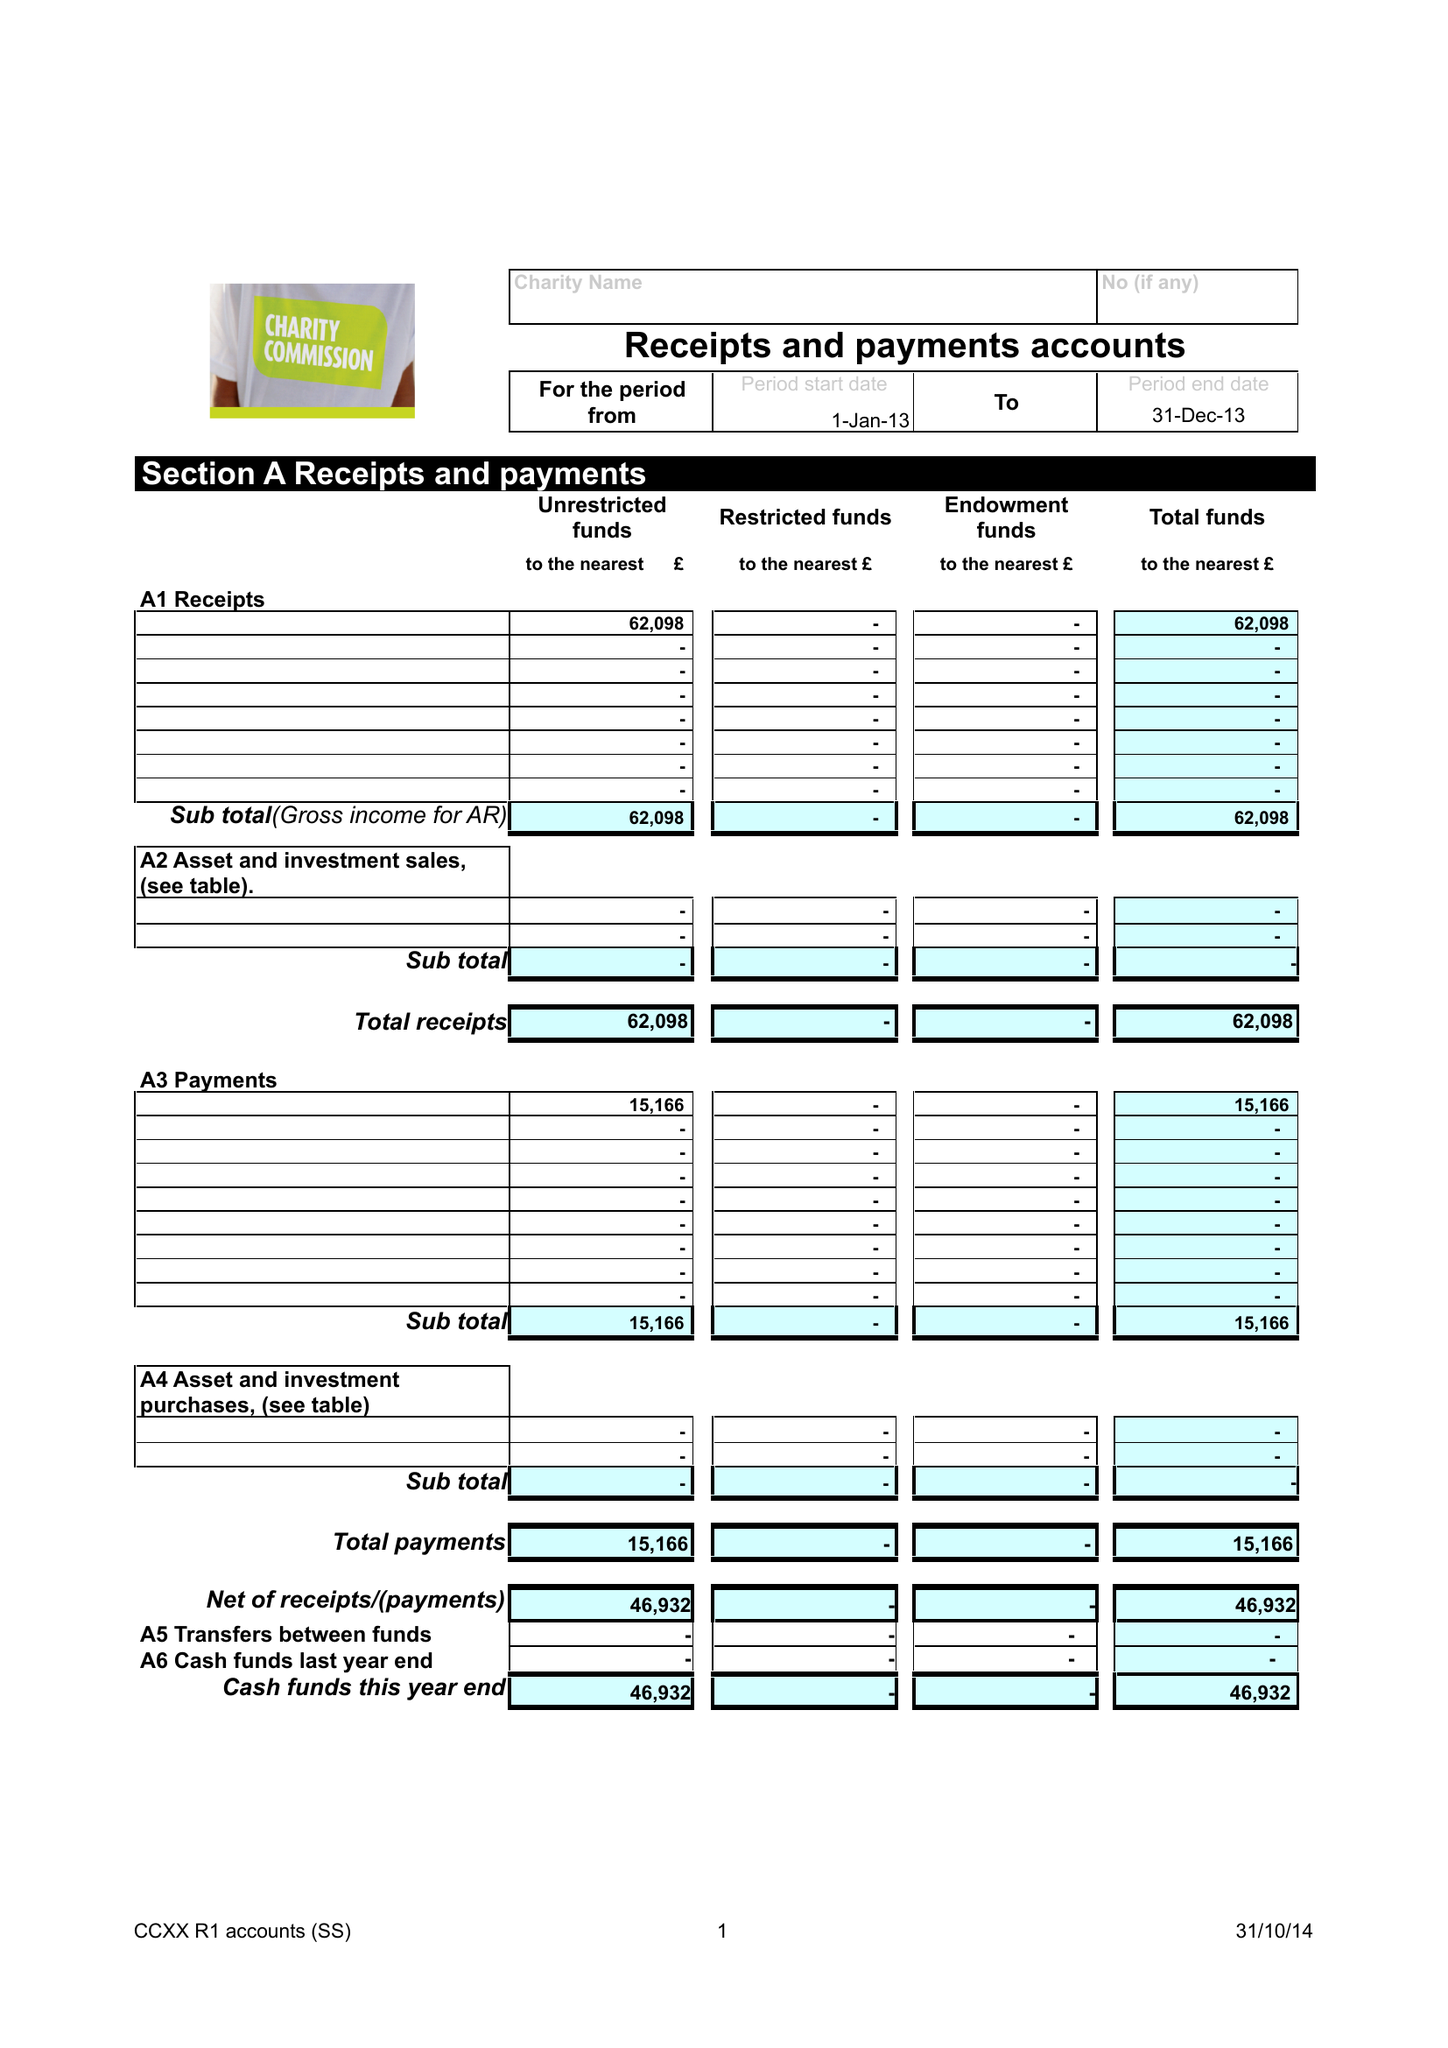What is the value for the spending_annually_in_british_pounds?
Answer the question using a single word or phrase. 15166.00 